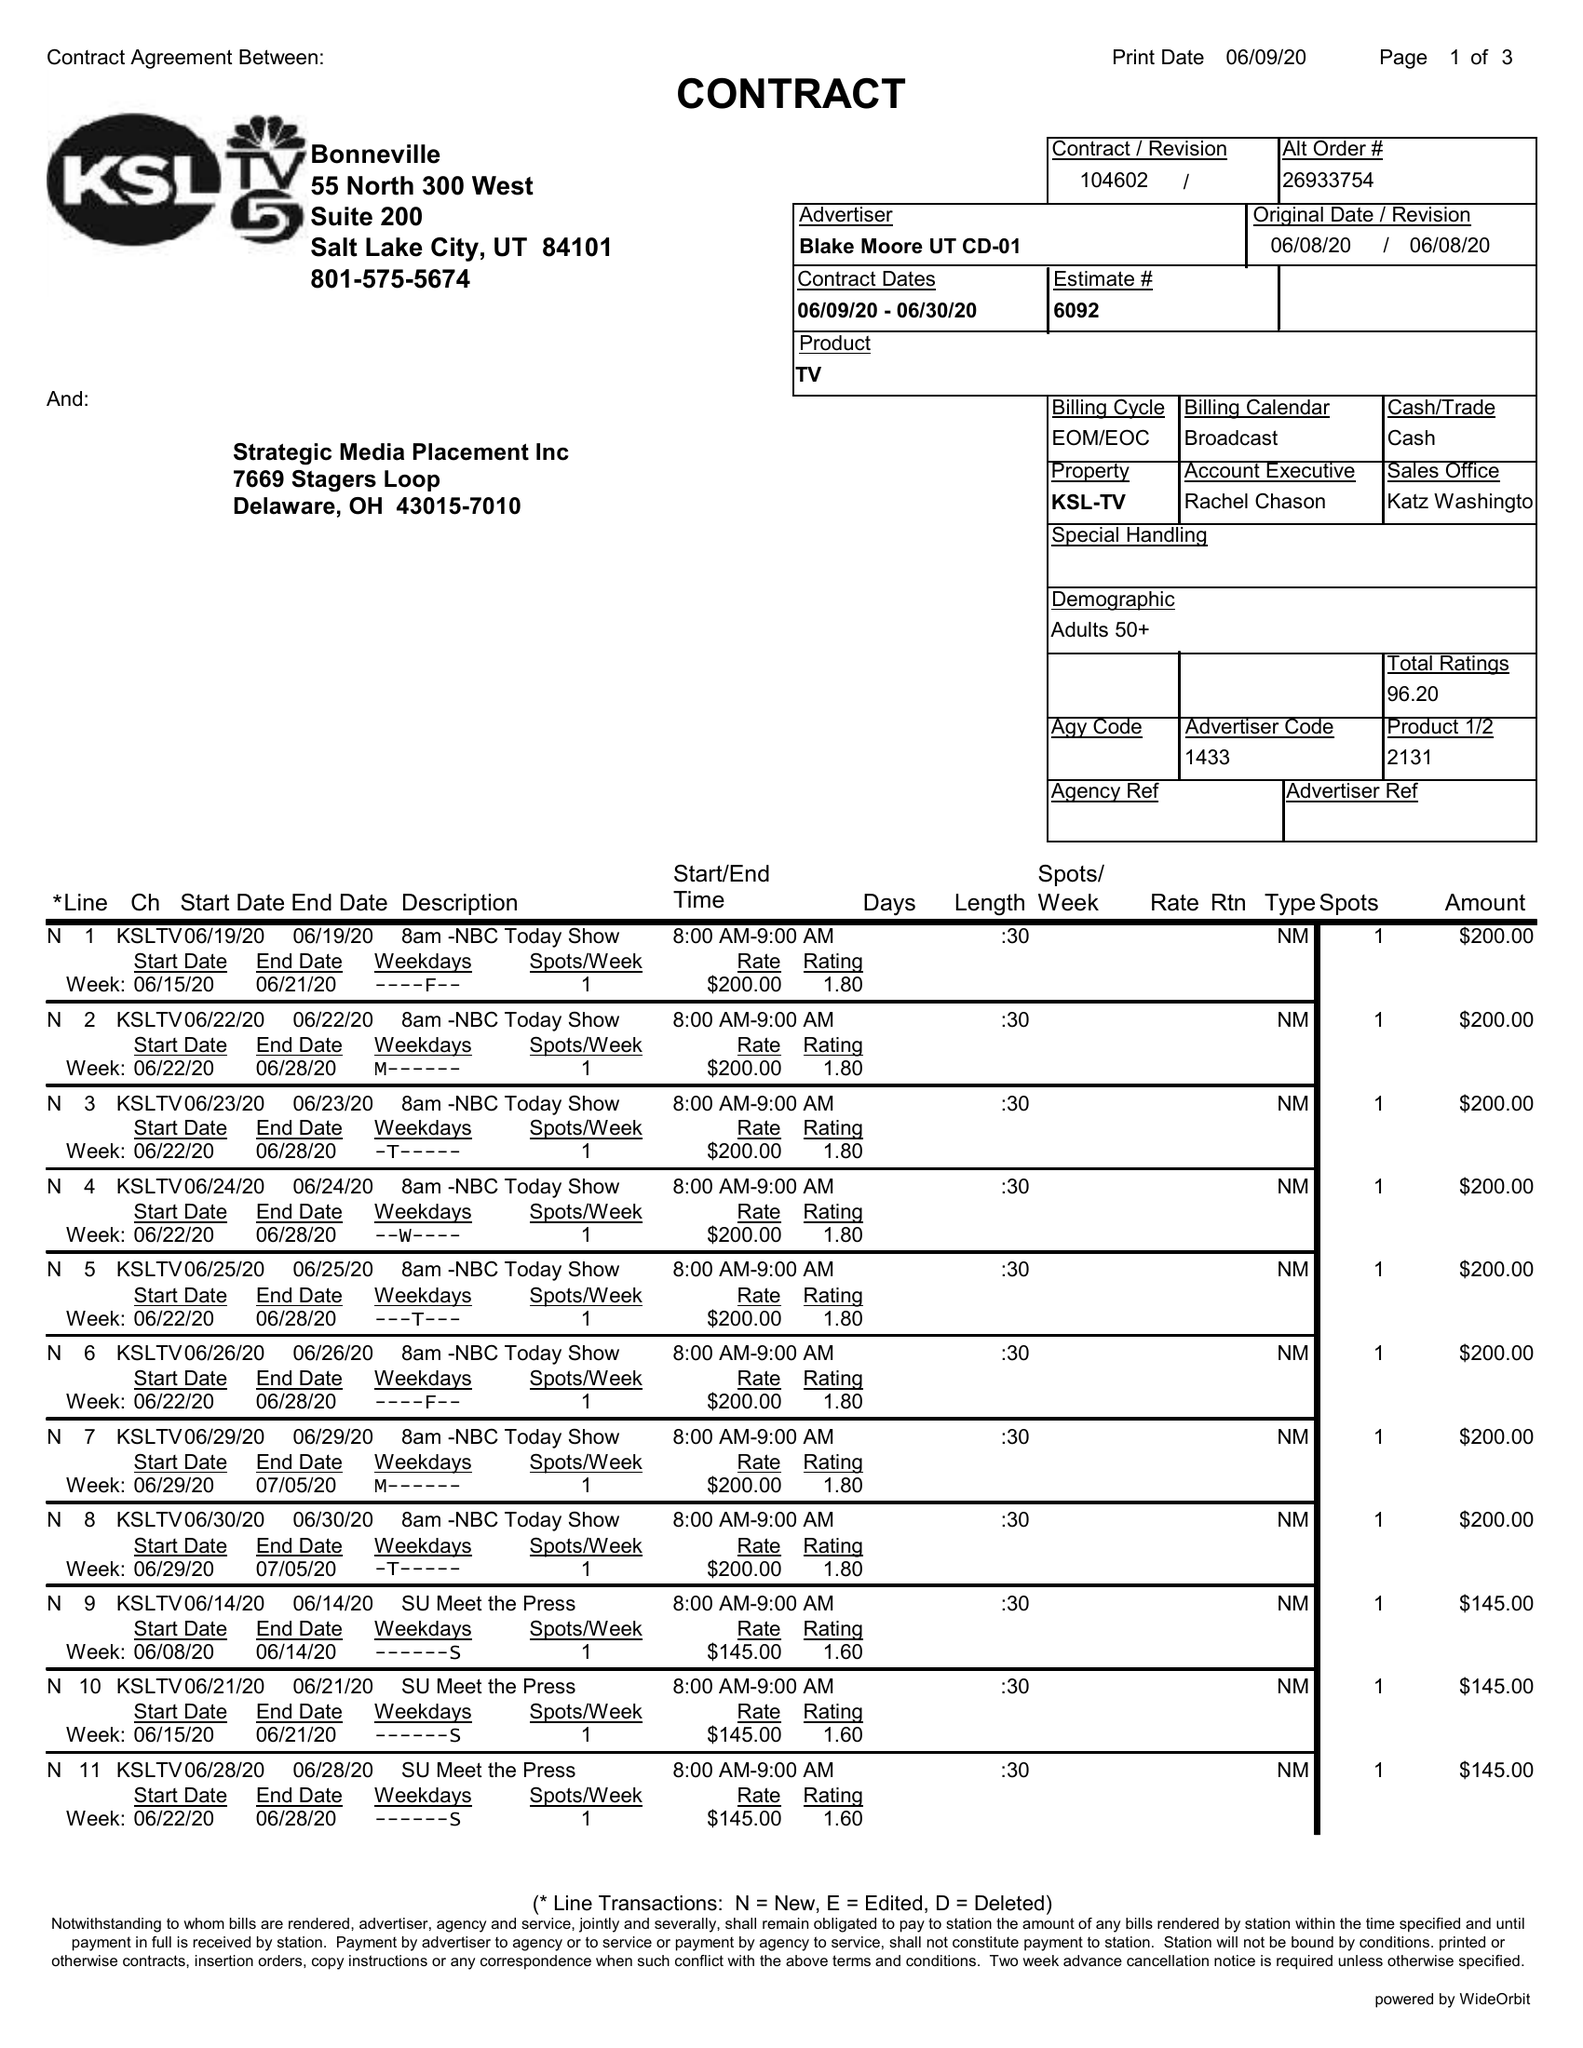What is the value for the gross_amount?
Answer the question using a single word or phrase. 11135.00 